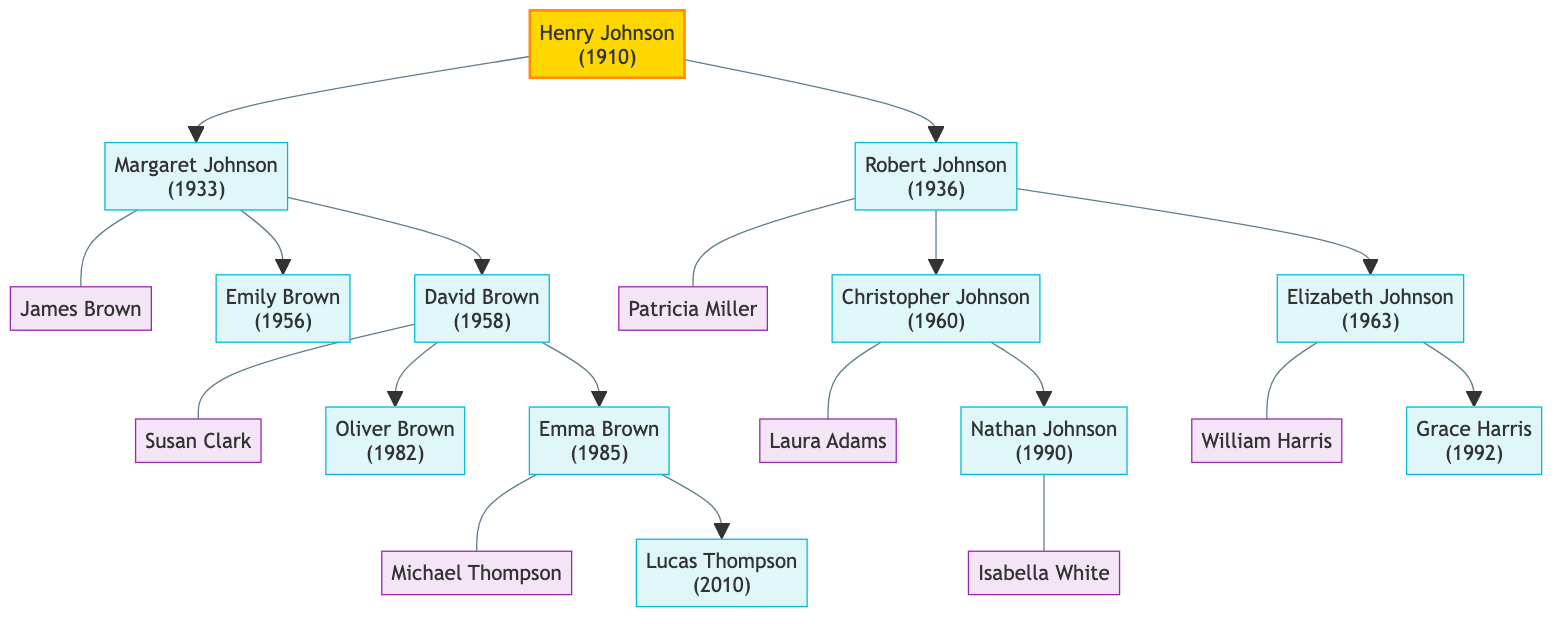What is the name of Henry Johnson's spouse? The diagram does not provide any information about a spouse for Henry Johnson, indicating that he may not have one listed in this lineage.
Answer: None How many children does Margaret Johnson have? Margaret Johnson has two children listed, Emily Brown and David Brown.
Answer: 2 Who is the parent of Nathan Johnson? Nathan Johnson is the child of Christopher Johnson and Laura Adams. By following the arrows from Henry Johnson to Robert Johnson, then to Christopher Johnson, we find Nathan as Christopher's child.
Answer: Christopher Johnson What year was Robert Johnson born? Robert Johnson's birth year is listed in the diagram as 1936.
Answer: 1936 How many grandchildren does Henry Johnson have? Counting the grandchildren, we have Oliver Brown, Emma Brown, Christopher Johnson's children Nathan Johnson, and Elizabeth Johnson's child Grace Harris, totaling five grandchildren.
Answer: 5 Which child of David Brown is married? David Brown's daughter, Emma Brown, is married to Michael Thompson, as indicated in the diagram.
Answer: Emma Brown What is the birth year of Lucas Thompson? Lucas Thompson's birth year is explicitly stated as 2010 in the diagram.
Answer: 2010 Who are the spouses of Robert Johnson's children? The spouses of Robert Johnson's children are Laura Adams for Christopher Johnson and William Harris for Elizabeth Johnson, as depicted in the diagram.
Answer: Laura Adams and William Harris How many descendants does Margaret Johnson have? Margaret Johnson has four descendants: Emily Brown (no children), David Brown (two children), resulting in a total of four descendants.
Answer: 4 